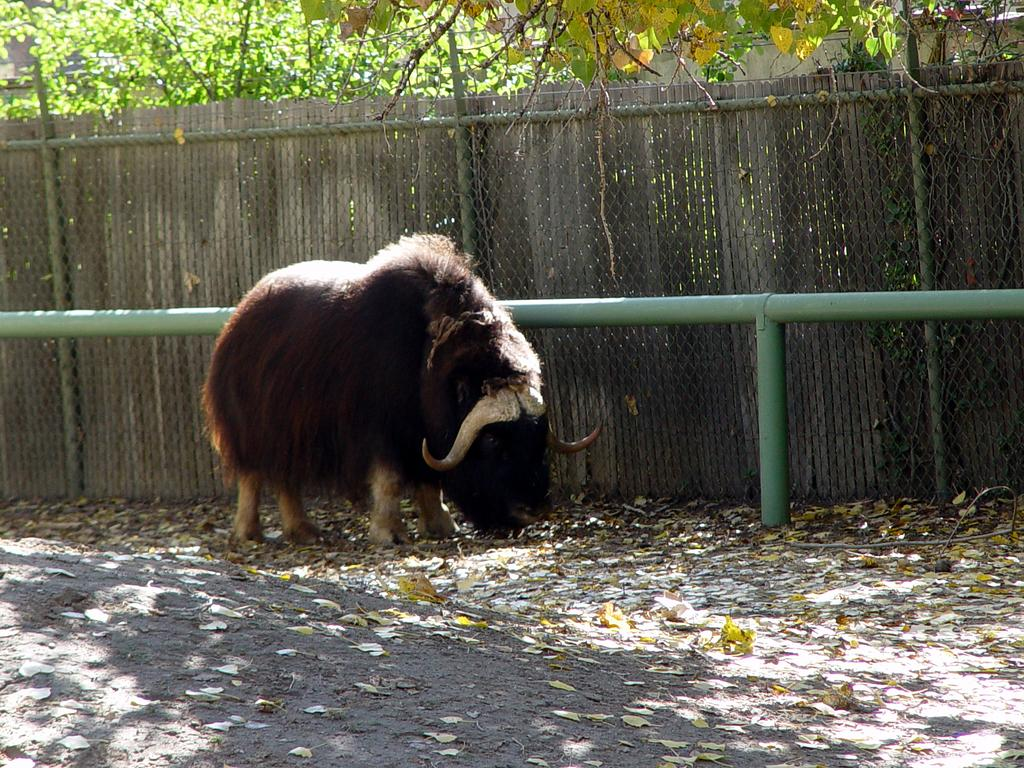What animal is in the middle of the image? There is a muskox in the middle of the image. What can be seen in the background of the image? There is a fence in the background of the image. What type of vegetation is visible at the top of the image? Trees are visible at the top of the image. What type of circle can be seen in the image? There is no circle present in the image. How many clovers are visible in the image? There are no clovers present in the image. 